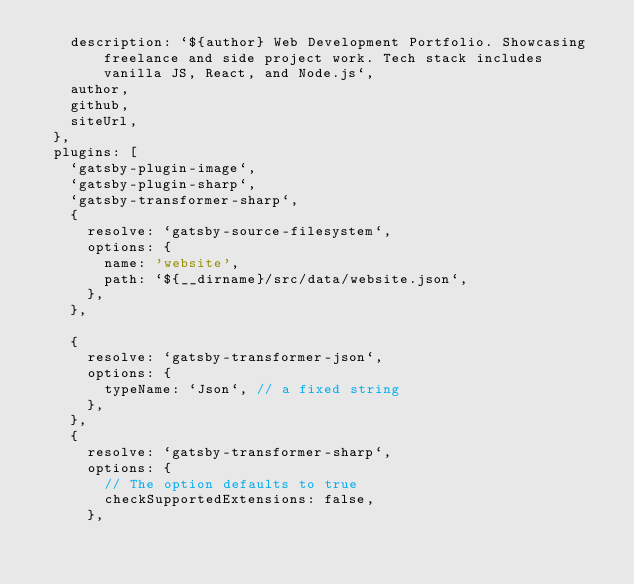Convert code to text. <code><loc_0><loc_0><loc_500><loc_500><_JavaScript_>    description: `${author} Web Development Portfolio. Showcasing freelance and side project work. Tech stack includes vanilla JS, React, and Node.js`,
    author,
    github,
    siteUrl,
  },
  plugins: [
    `gatsby-plugin-image`,
    `gatsby-plugin-sharp`,
    `gatsby-transformer-sharp`,
    {
      resolve: `gatsby-source-filesystem`,
      options: {
        name: 'website',
        path: `${__dirname}/src/data/website.json`,
      },
    },

    {
      resolve: `gatsby-transformer-json`,
      options: {
        typeName: `Json`, // a fixed string
      },
    },
    {
      resolve: `gatsby-transformer-sharp`,
      options: {
        // The option defaults to true
        checkSupportedExtensions: false,
      },</code> 